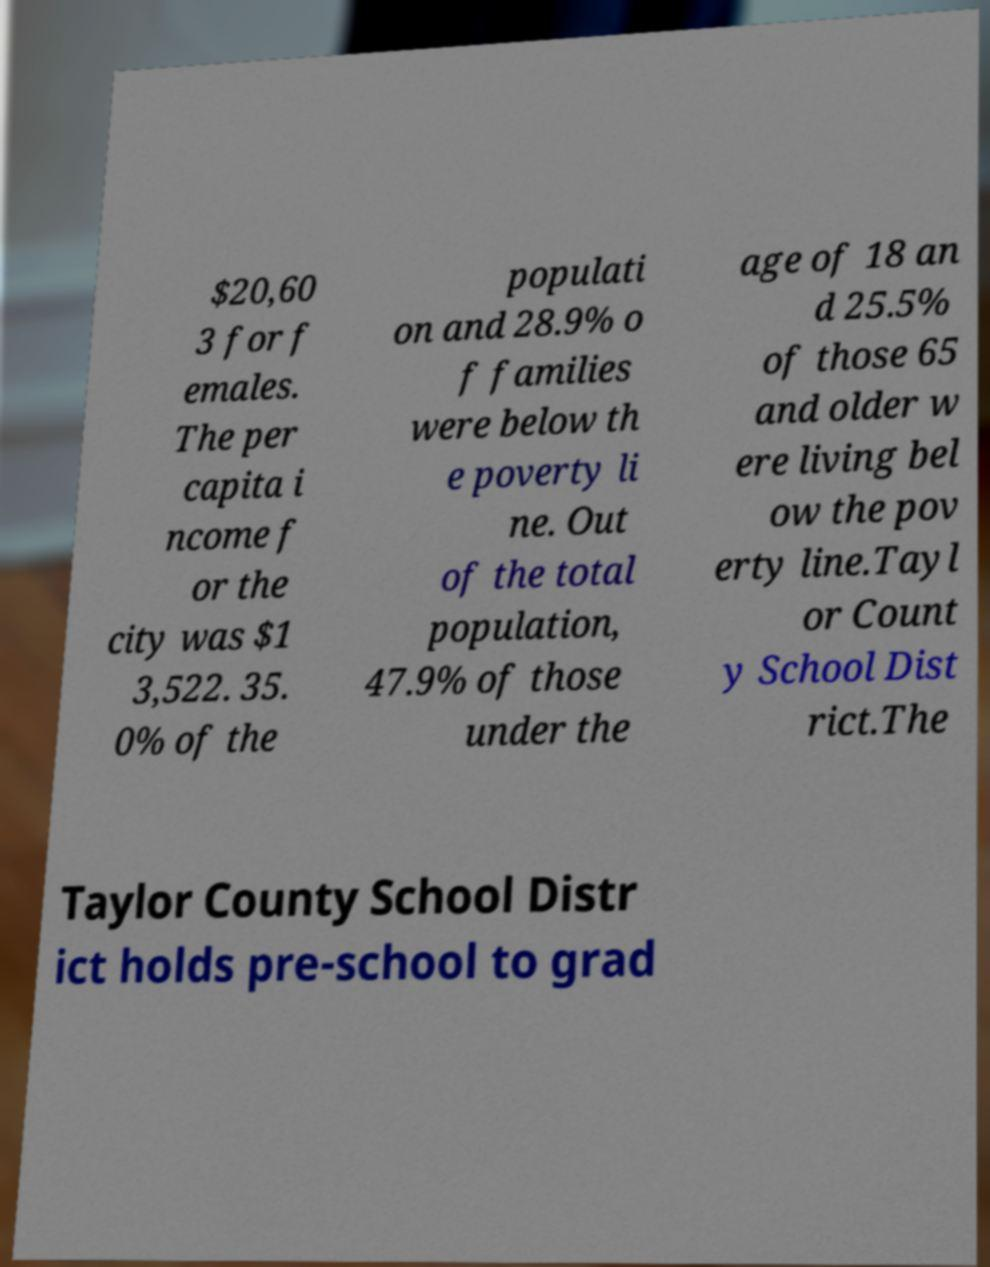For documentation purposes, I need the text within this image transcribed. Could you provide that? $20,60 3 for f emales. The per capita i ncome f or the city was $1 3,522. 35. 0% of the populati on and 28.9% o f families were below th e poverty li ne. Out of the total population, 47.9% of those under the age of 18 an d 25.5% of those 65 and older w ere living bel ow the pov erty line.Tayl or Count y School Dist rict.The Taylor County School Distr ict holds pre-school to grad 